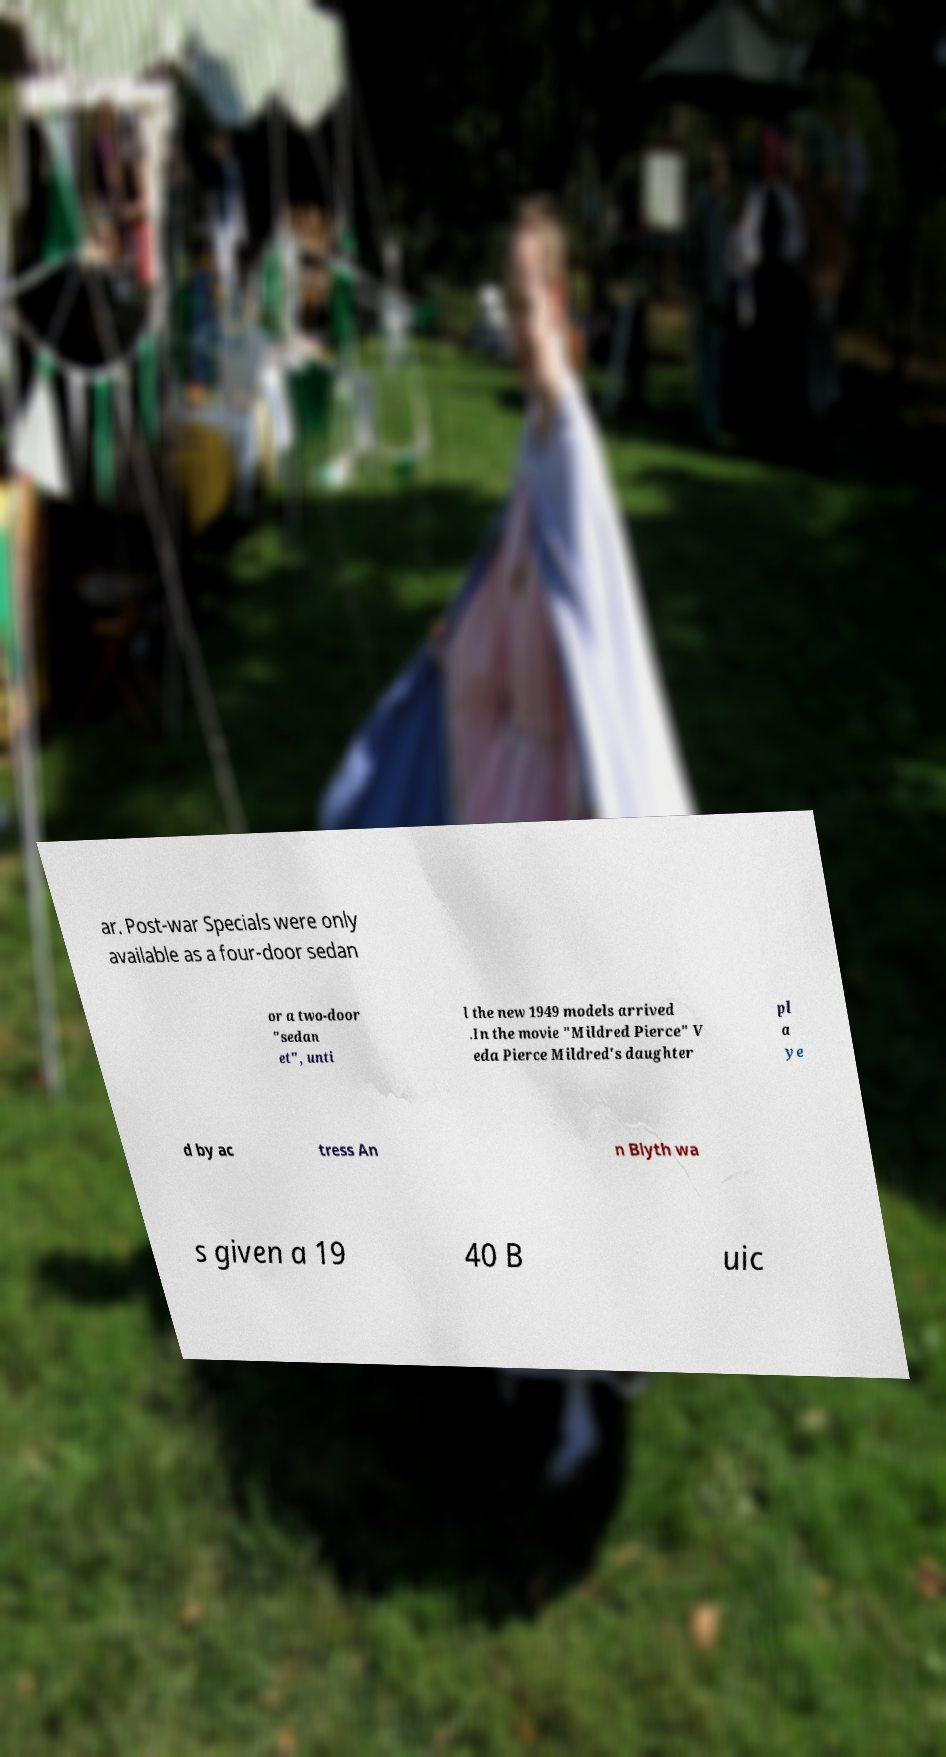Could you assist in decoding the text presented in this image and type it out clearly? ar. Post-war Specials were only available as a four-door sedan or a two-door "sedan et", unti l the new 1949 models arrived .In the movie "Mildred Pierce" V eda Pierce Mildred's daughter pl a ye d by ac tress An n Blyth wa s given a 19 40 B uic 